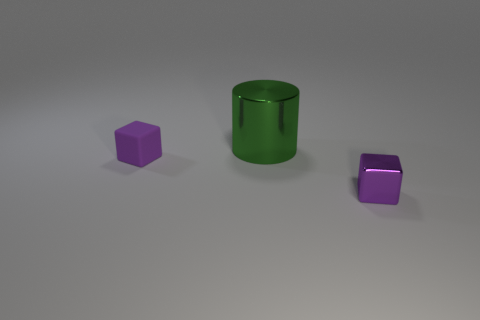There is another object that is the same material as the green object; what size is it? The object with the same material as the green cylinder appears to be the purple cube on the right side of the image, and it is small in size compared to the green cylinder. 